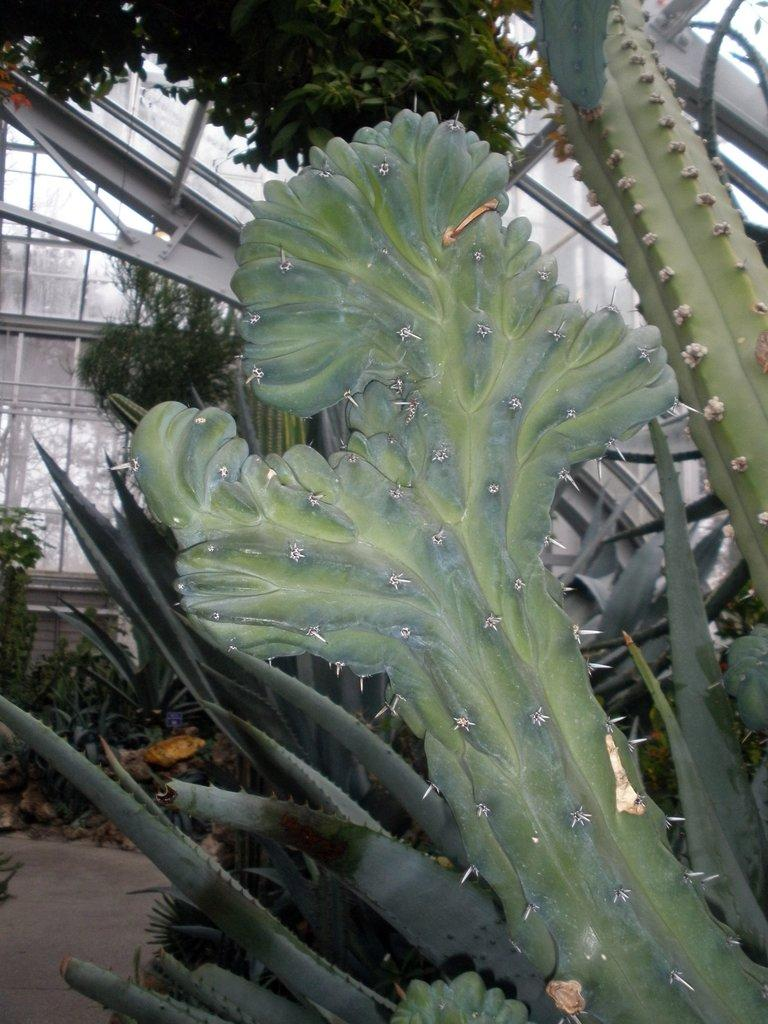What type of vegetation can be seen in the image? There are plants and trees in the image. What type of structure is present in the image? There is a house in the image. What type of underwear is the secretary wearing in the image? There is no secretary or underwear present in the image. 